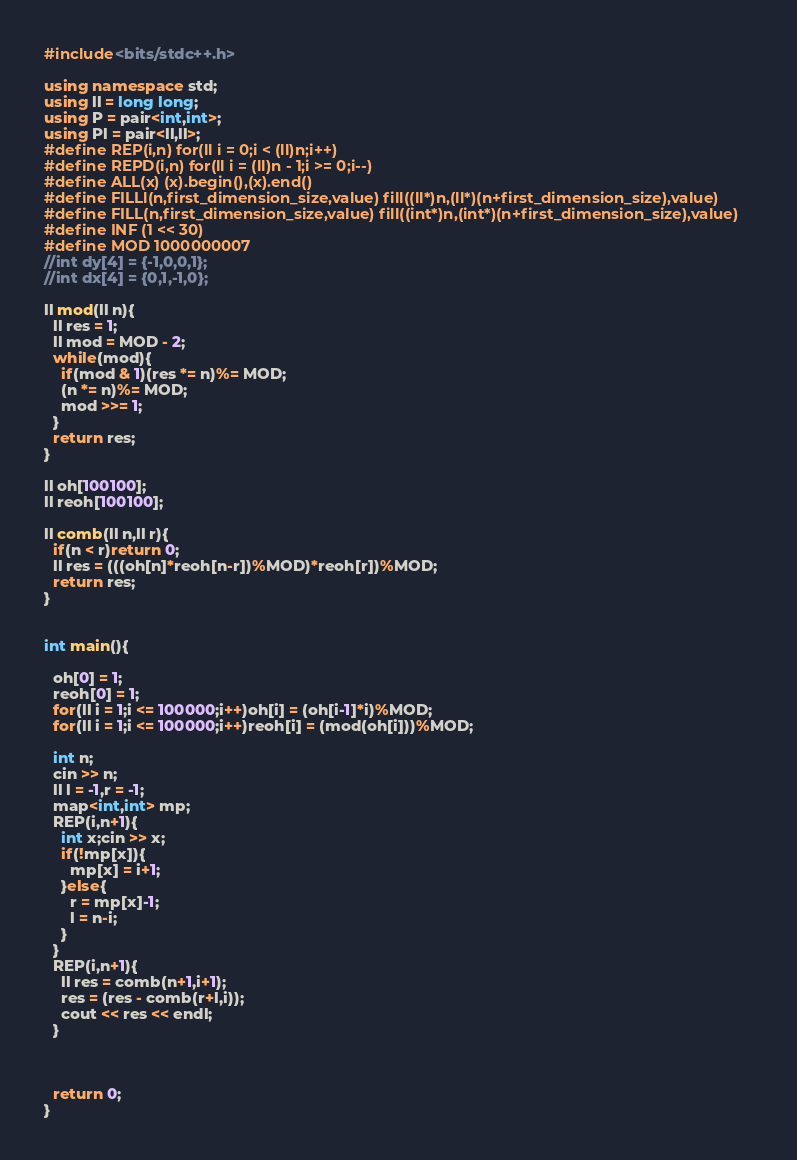Convert code to text. <code><loc_0><loc_0><loc_500><loc_500><_C++_>#include<bits/stdc++.h>

using namespace std;
using ll = long long;
using P = pair<int,int>;
using Pl = pair<ll,ll>;
#define REP(i,n) for(ll i = 0;i < (ll)n;i++)
#define REPD(i,n) for(ll i = (ll)n - 1;i >= 0;i--)
#define ALL(x) (x).begin(),(x).end()
#define FILLl(n,first_dimension_size,value) fill((ll*)n,(ll*)(n+first_dimension_size),value)
#define FILL(n,first_dimension_size,value) fill((int*)n,(int*)(n+first_dimension_size),value)
#define INF (1 << 30)
#define MOD 1000000007
//int dy[4] = {-1,0,0,1};
//int dx[4] = {0,1,-1,0};

ll mod(ll n){
  ll res = 1;
  ll mod = MOD - 2;
  while(mod){
    if(mod & 1)(res *= n)%= MOD;
    (n *= n)%= MOD;
    mod >>= 1;
  }
  return res;
}

ll oh[100100];
ll reoh[100100];

ll comb(ll n,ll r){
  if(n < r)return 0;
  ll res = (((oh[n]*reoh[n-r])%MOD)*reoh[r])%MOD;
  return res;
}


int main(){
  
  oh[0] = 1;
  reoh[0] = 1;
  for(ll i = 1;i <= 100000;i++)oh[i] = (oh[i-1]*i)%MOD;
  for(ll i = 1;i <= 100000;i++)reoh[i] = (mod(oh[i]))%MOD;
  
  int n;
  cin >> n;
  ll l = -1,r = -1;
  map<int,int> mp;
  REP(i,n+1){
    int x;cin >> x;
    if(!mp[x]){
      mp[x] = i+1;
    }else{
      r = mp[x]-1;
      l = n-i;
    }
  }
  REP(i,n+1){
    ll res = comb(n+1,i+1);
    res = (res - comb(r+l,i));
    cout << res << endl;
  }

  

  return 0;
}
</code> 